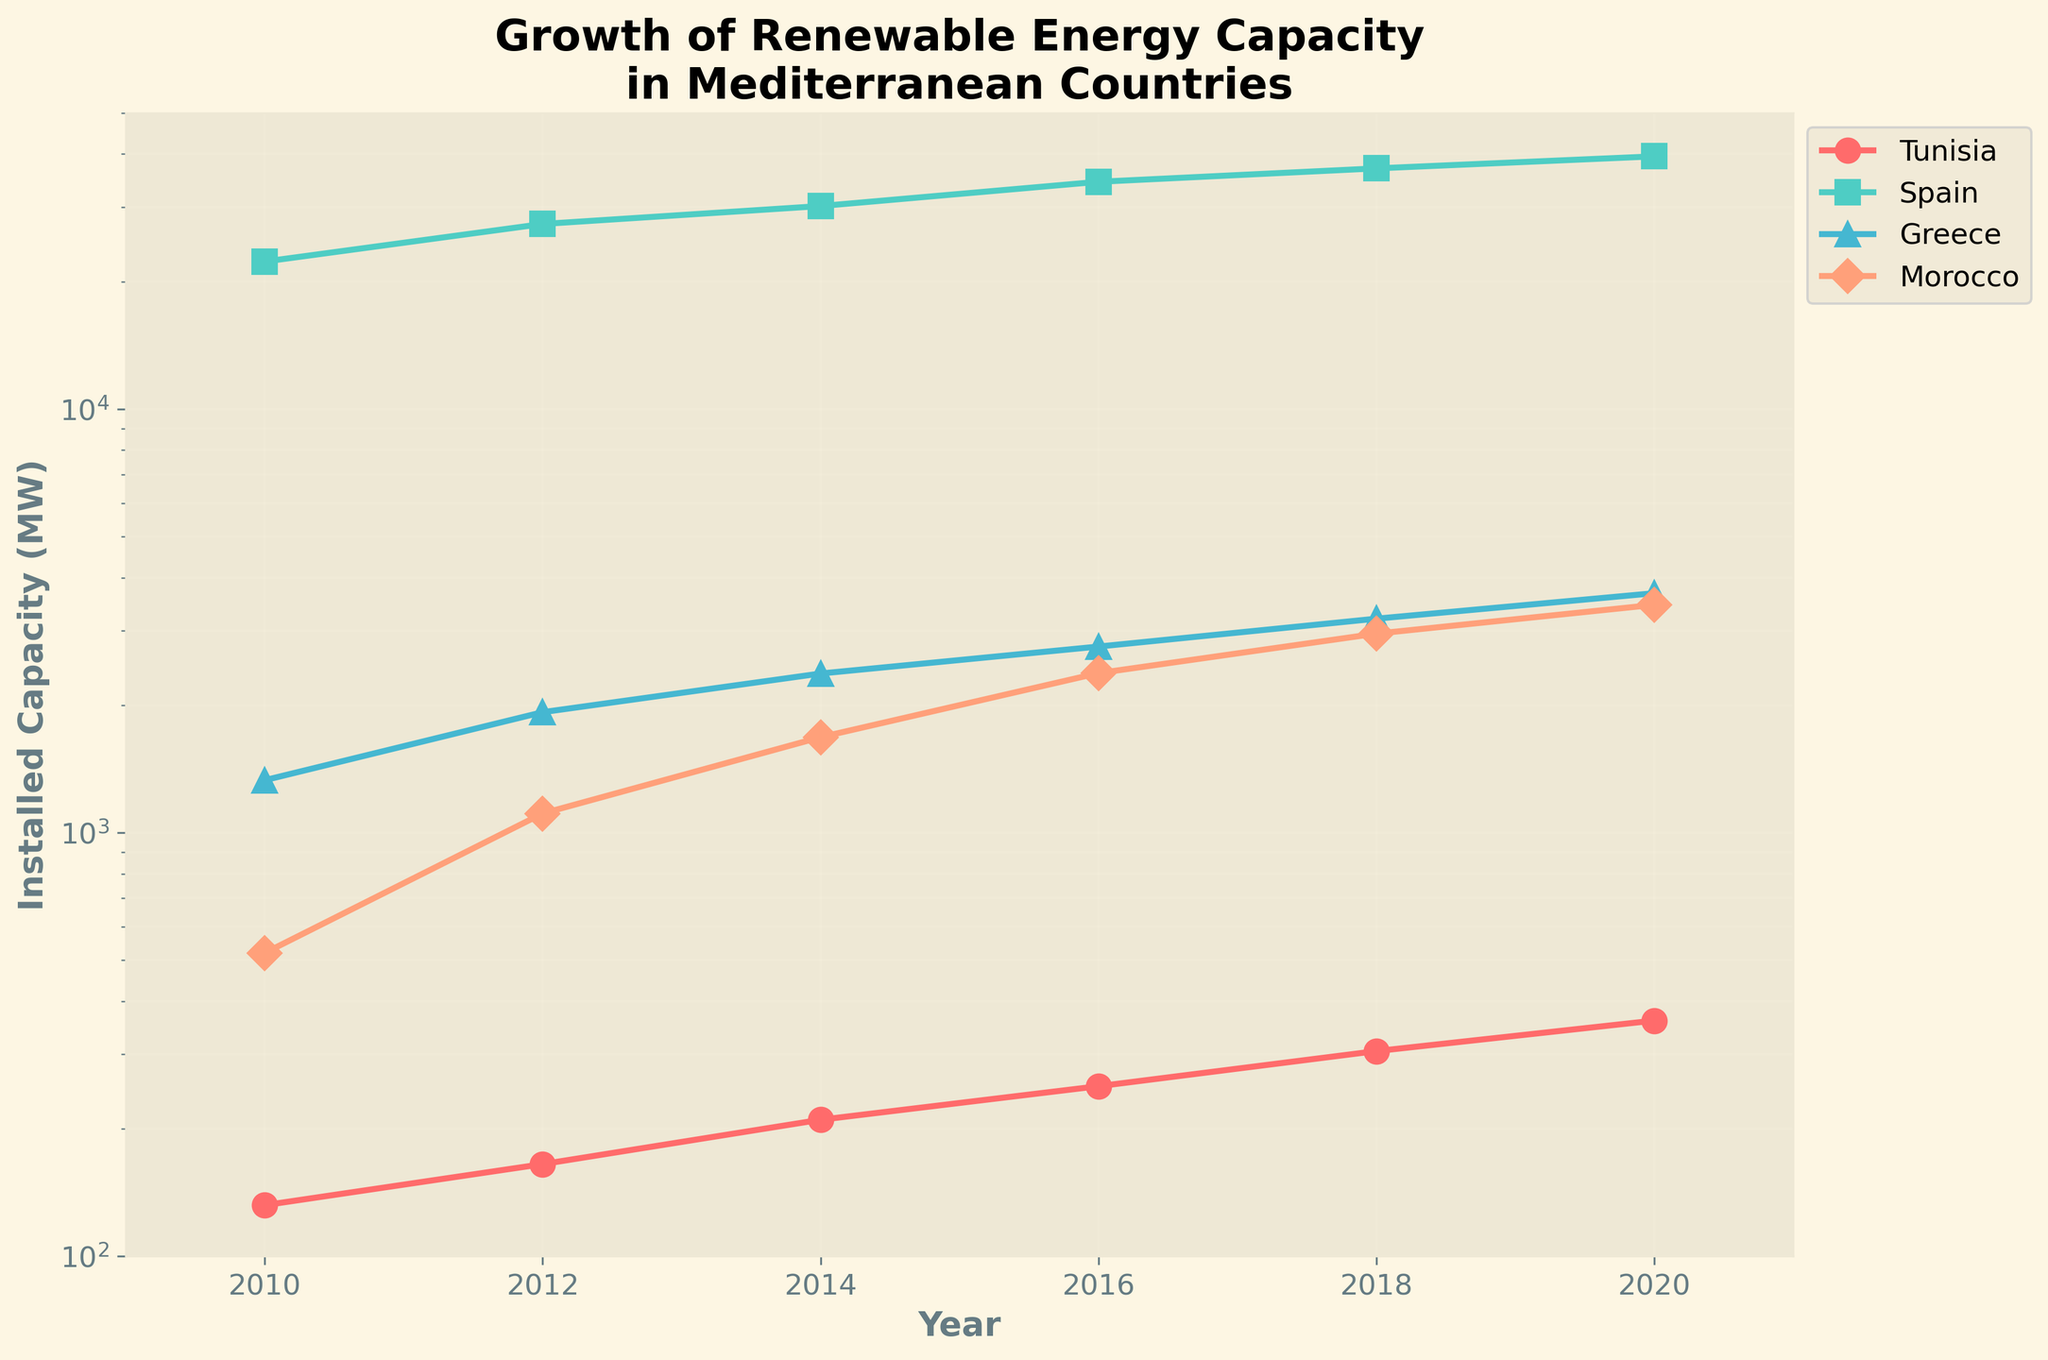Which country had the highest installed renewable energy capacity in 2010? By looking at the plot, we can compare the positions of the data points for the year 2010 on the Y-axis. Spain's data point is the highest in 2010.
Answer: Spain How much did Tunisia's installed renewable energy capacity increase between 2010 and 2020? For Tunisia, locate the data points for the years 2010 and 2020 on the Y-axis. Subtract the 2010 value (132 MW) from the 2020 value (360 MW).
Answer: 228 MW Which country showed the least growth in installed renewable energy capacity from 2010 to 2020? Compare the difference between the values for each country from 2010 to 2020. The smallest difference is observed for Greece, which grew from 1330 MW to 3675 MW.
Answer: Greece In 2018, did Morocco or Tunisia have a higher installed renewable energy capacity? Locate the data points for Morocco and Tunisia in 2018 on the plot. Compare their positions on the Y-axis. Morocco's value is higher at 2950 MW compared to Tunisia's 305 MW.
Answer: Morocco What is the average annual growth rate of installed renewable energy capacity for Greece from 2010 to 2020? Calculate the total growth over 10 years (3675 MW - 1330 MW) and then divide by the number of years (10).
Answer: Approximately 234.5 MW/year What was the trend in Tunisia’s installed renewable energy capacity from 2010 to 2020? Observe the positions of Tunisia's data points from 2010 to 2020 on the Y-axis. The data points show a consistent upward trend, indicating steady growth.
Answer: Steady growth How does Spain's growth in installed renewable energy capacity from 2010 to 2020 compare to Morocco's? Compare the difference in capacity for both countries from 2010 to 2020. Spain's growth is from 22300 MW to 39500 MW, and Morocco's growth is from 520 MW to 3450 MW. Spain experienced a larger increase in absolute terms.
Answer: Spain had a larger increase What is the title of the plot, and what does it indicate about the data shown? The title is "Growth of Renewable Energy Capacity in Mediterranean Countries." It indicates that the plot shows how renewable energy capacity has increased over time in Mediterranean countries like Tunisia, Spain, Greece, and Morocco.
Answer: Growth of Renewable Energy Capacity in Mediterranean Countries Which country had the most significant year-over-year increase in installed renewable energy capacity at any point in time, and in which year? To find the most significant year-over-year increase, observe the biggest jump between two consecutive data points for any country. For Morocco, from 2010 (520 MW) to 2012 (1110 MW), the increase is 590 MW.
Answer: Morocco, 2010-2012 Excluding Tunisia, which country had the slowest growth in the installed capacity from 2010 to 2020? Compare the growth in capacity for Spain, Greece, and Morocco from 2010 to 2020. Greece shows the slowest growth, increasing from 1330 MW to 3675 MW.
Answer: Greece 